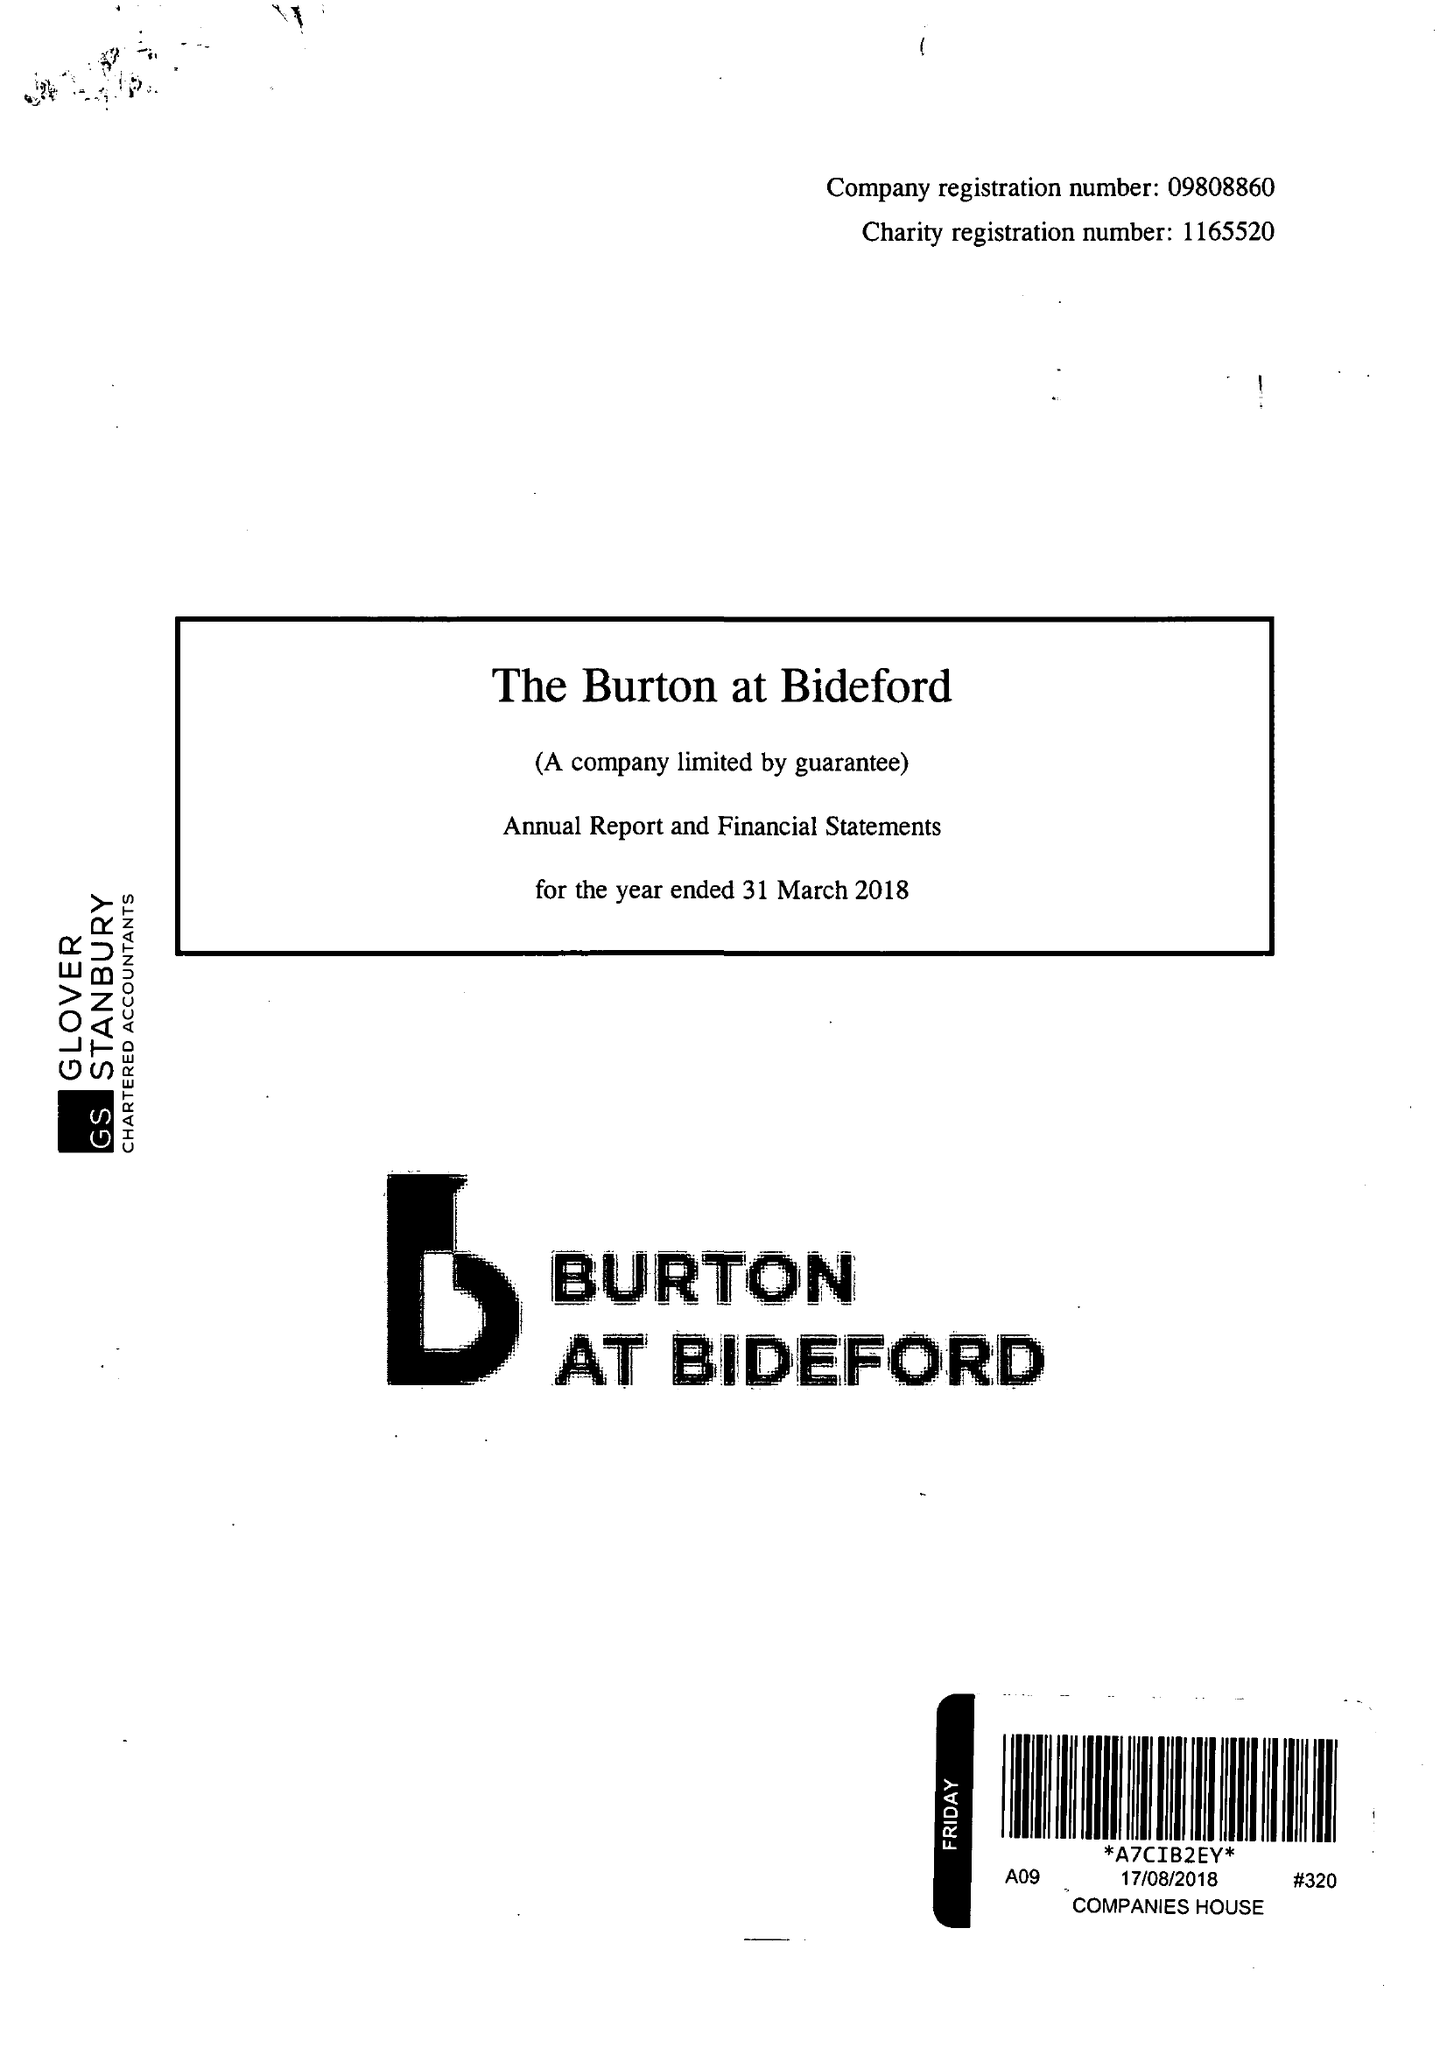What is the value for the charity_number?
Answer the question using a single word or phrase. 1165520 